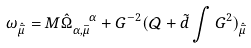<formula> <loc_0><loc_0><loc_500><loc_500>\omega _ { { \hat { \bar { \mu } } } } = M \hat { \Omega } _ { \alpha , \bar { \mu } } ^ { \text { \quad \ } \alpha } + G ^ { - 2 } ( \mathcal { Q } + { \tilde { d } } \int G ^ { 2 } ) _ { { \hat { \bar { \mu } } } }</formula> 